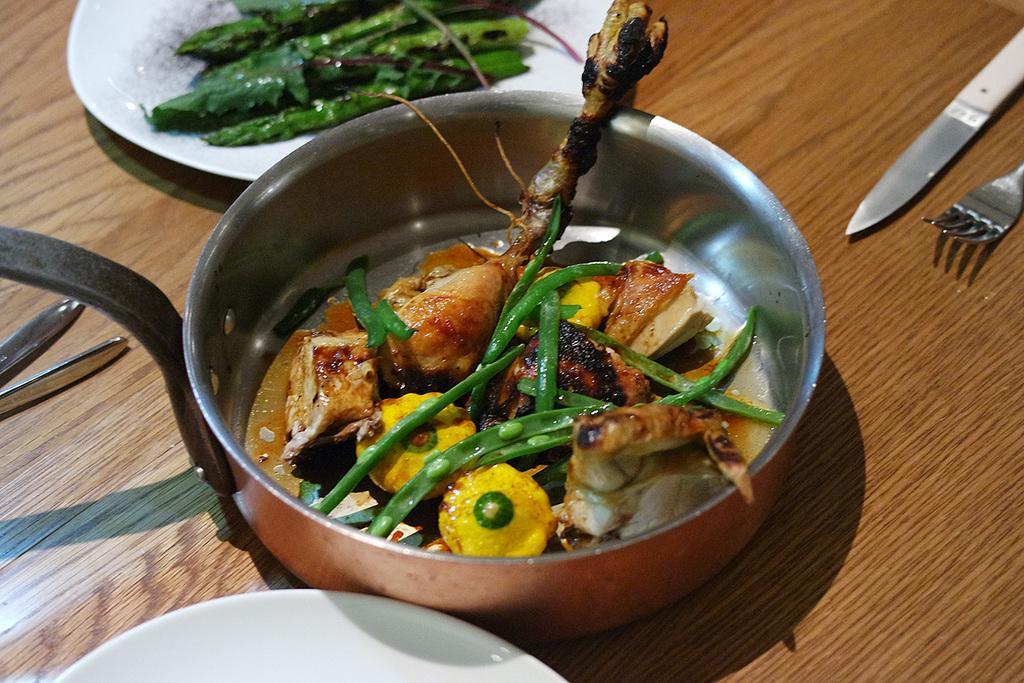In one or two sentences, can you explain what this image depicts? In the center of this picture we can see a utensil and a white color platter containing some food items are placed on the top of the wooden table and we can see a knife, fork and some other objects are placed on the top of the wooden table. 